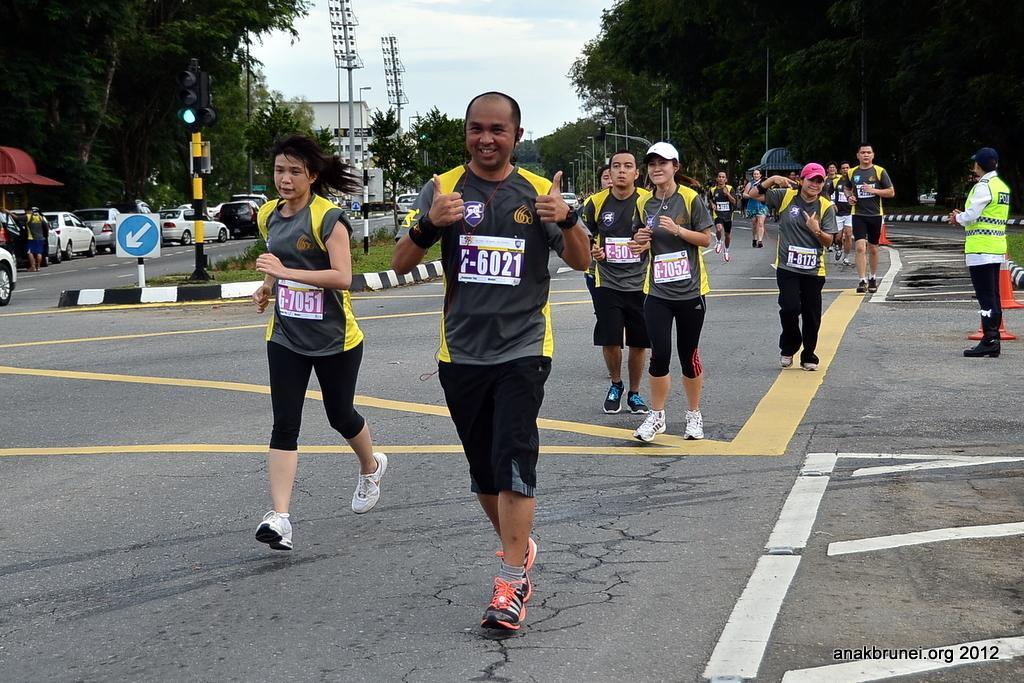How would you summarize this image in a sentence or two? In this image I can see few persons wearing black and yellow t shirts and black shorts are standing on the road. In the background I can see few vehicles on the road, few metal poles, a sign board, few street lights, few trees, a traffic signal, few buildings and the sky. 